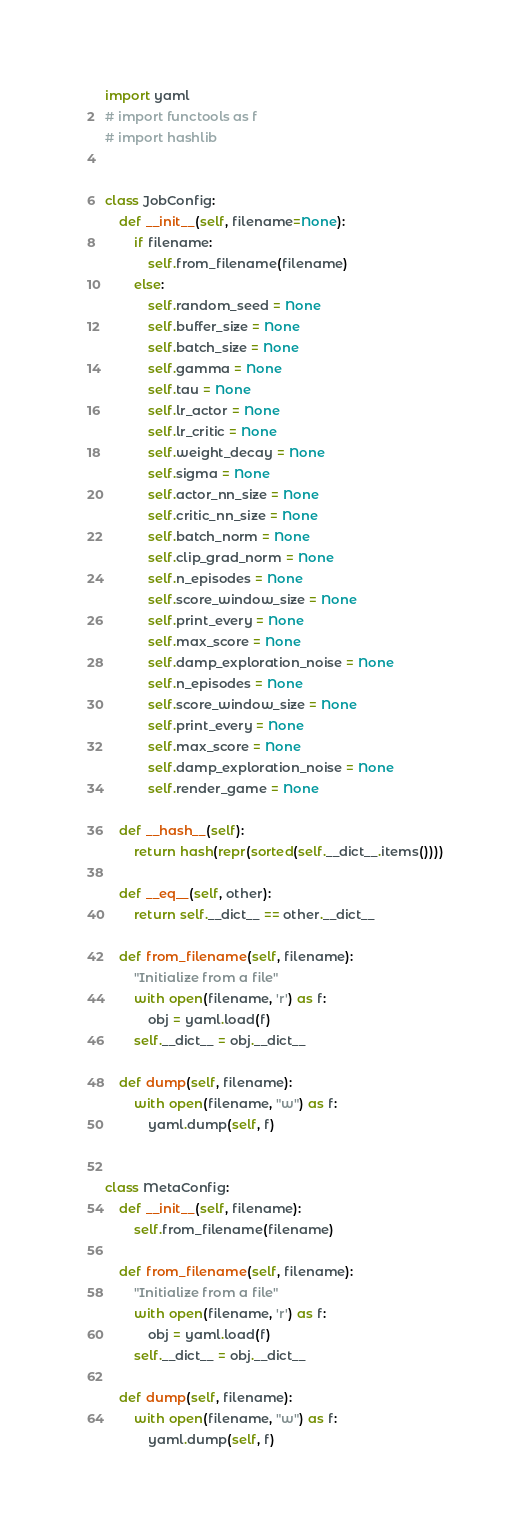Convert code to text. <code><loc_0><loc_0><loc_500><loc_500><_Python_>import yaml
# import functools as f
# import hashlib


class JobConfig:
    def __init__(self, filename=None):
        if filename:
            self.from_filename(filename)
        else:
            self.random_seed = None
            self.buffer_size = None
            self.batch_size = None
            self.gamma = None
            self.tau = None
            self.lr_actor = None
            self.lr_critic = None
            self.weight_decay = None
            self.sigma = None
            self.actor_nn_size = None
            self.critic_nn_size = None
            self.batch_norm = None
            self.clip_grad_norm = None
            self.n_episodes = None
            self.score_window_size = None
            self.print_every = None
            self.max_score = None
            self.damp_exploration_noise = None
            self.n_episodes = None
            self.score_window_size = None
            self.print_every = None
            self.max_score = None
            self.damp_exploration_noise = None
            self.render_game = None

    def __hash__(self):
        return hash(repr(sorted(self.__dict__.items())))

    def __eq__(self, other):
        return self.__dict__ == other.__dict__

    def from_filename(self, filename):
        "Initialize from a file"
        with open(filename, 'r') as f:
            obj = yaml.load(f)
        self.__dict__ = obj.__dict__

    def dump(self, filename):
        with open(filename, "w") as f:
            yaml.dump(self, f)


class MetaConfig:
    def __init__(self, filename):
        self.from_filename(filename)

    def from_filename(self, filename):
        "Initialize from a file"
        with open(filename, 'r') as f:
            obj = yaml.load(f)
        self.__dict__ = obj.__dict__

    def dump(self, filename):
        with open(filename, "w") as f:
            yaml.dump(self, f)
</code> 